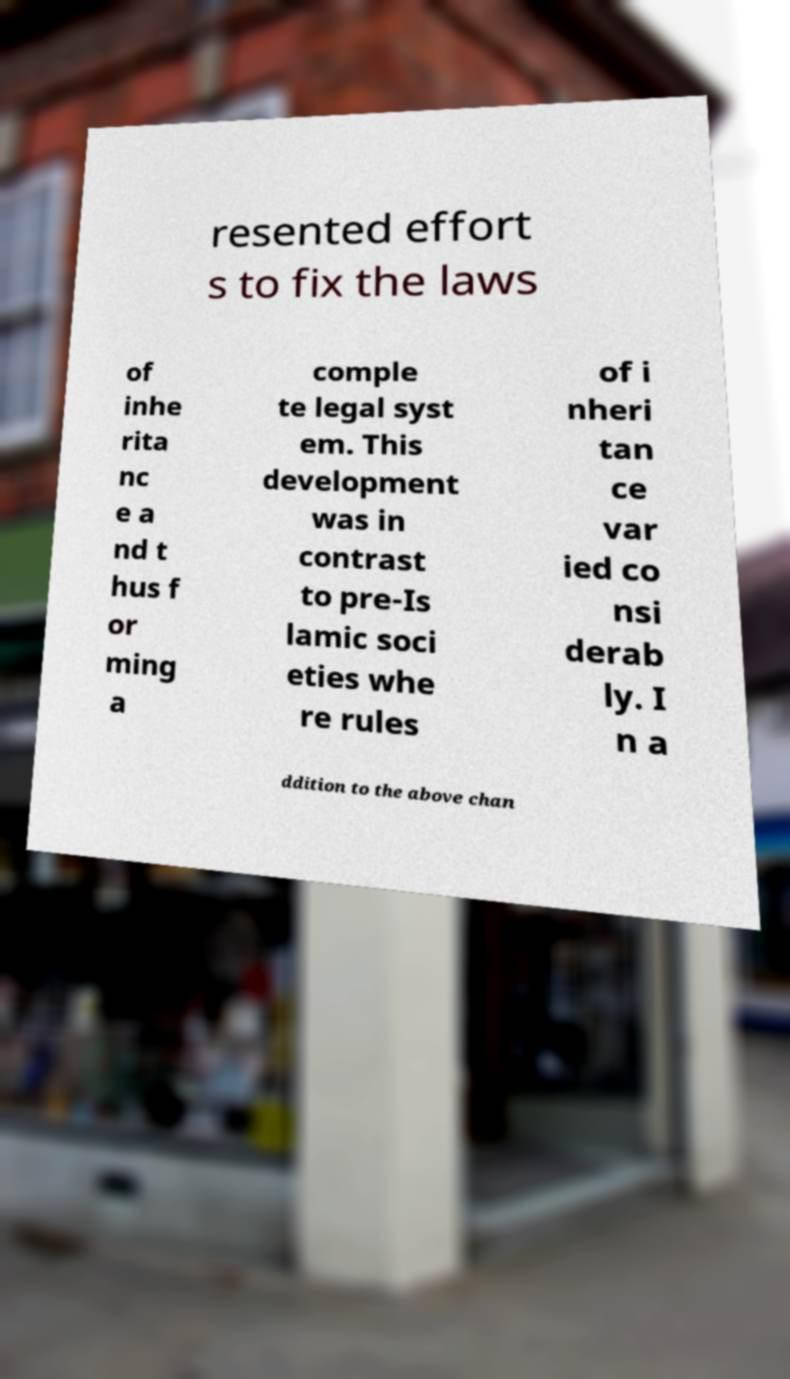For documentation purposes, I need the text within this image transcribed. Could you provide that? resented effort s to fix the laws of inhe rita nc e a nd t hus f or ming a comple te legal syst em. This development was in contrast to pre-Is lamic soci eties whe re rules of i nheri tan ce var ied co nsi derab ly. I n a ddition to the above chan 